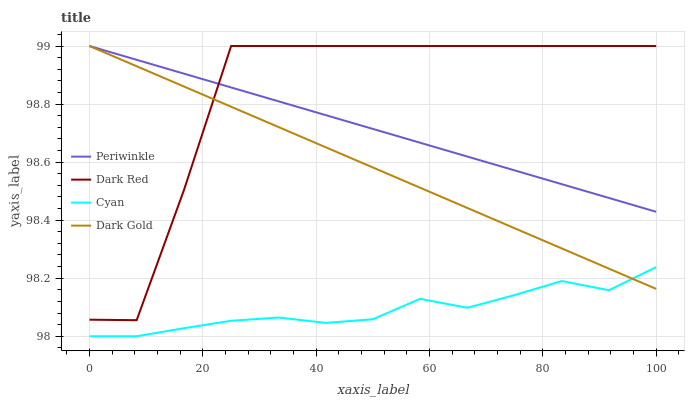Does Dark Gold have the minimum area under the curve?
Answer yes or no. No. Does Dark Gold have the maximum area under the curve?
Answer yes or no. No. Is Dark Gold the smoothest?
Answer yes or no. No. Is Dark Gold the roughest?
Answer yes or no. No. Does Dark Gold have the lowest value?
Answer yes or no. No. Does Cyan have the highest value?
Answer yes or no. No. Is Cyan less than Periwinkle?
Answer yes or no. Yes. Is Dark Red greater than Cyan?
Answer yes or no. Yes. Does Cyan intersect Periwinkle?
Answer yes or no. No. 